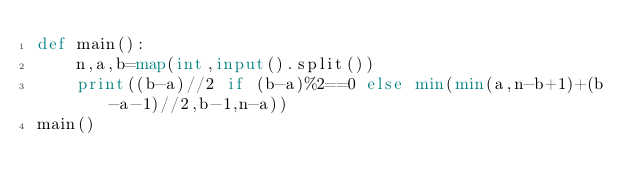Convert code to text. <code><loc_0><loc_0><loc_500><loc_500><_Python_>def main():
    n,a,b=map(int,input().split())
    print((b-a)//2 if (b-a)%2==0 else min(min(a,n-b+1)+(b-a-1)//2,b-1,n-a))
main()</code> 